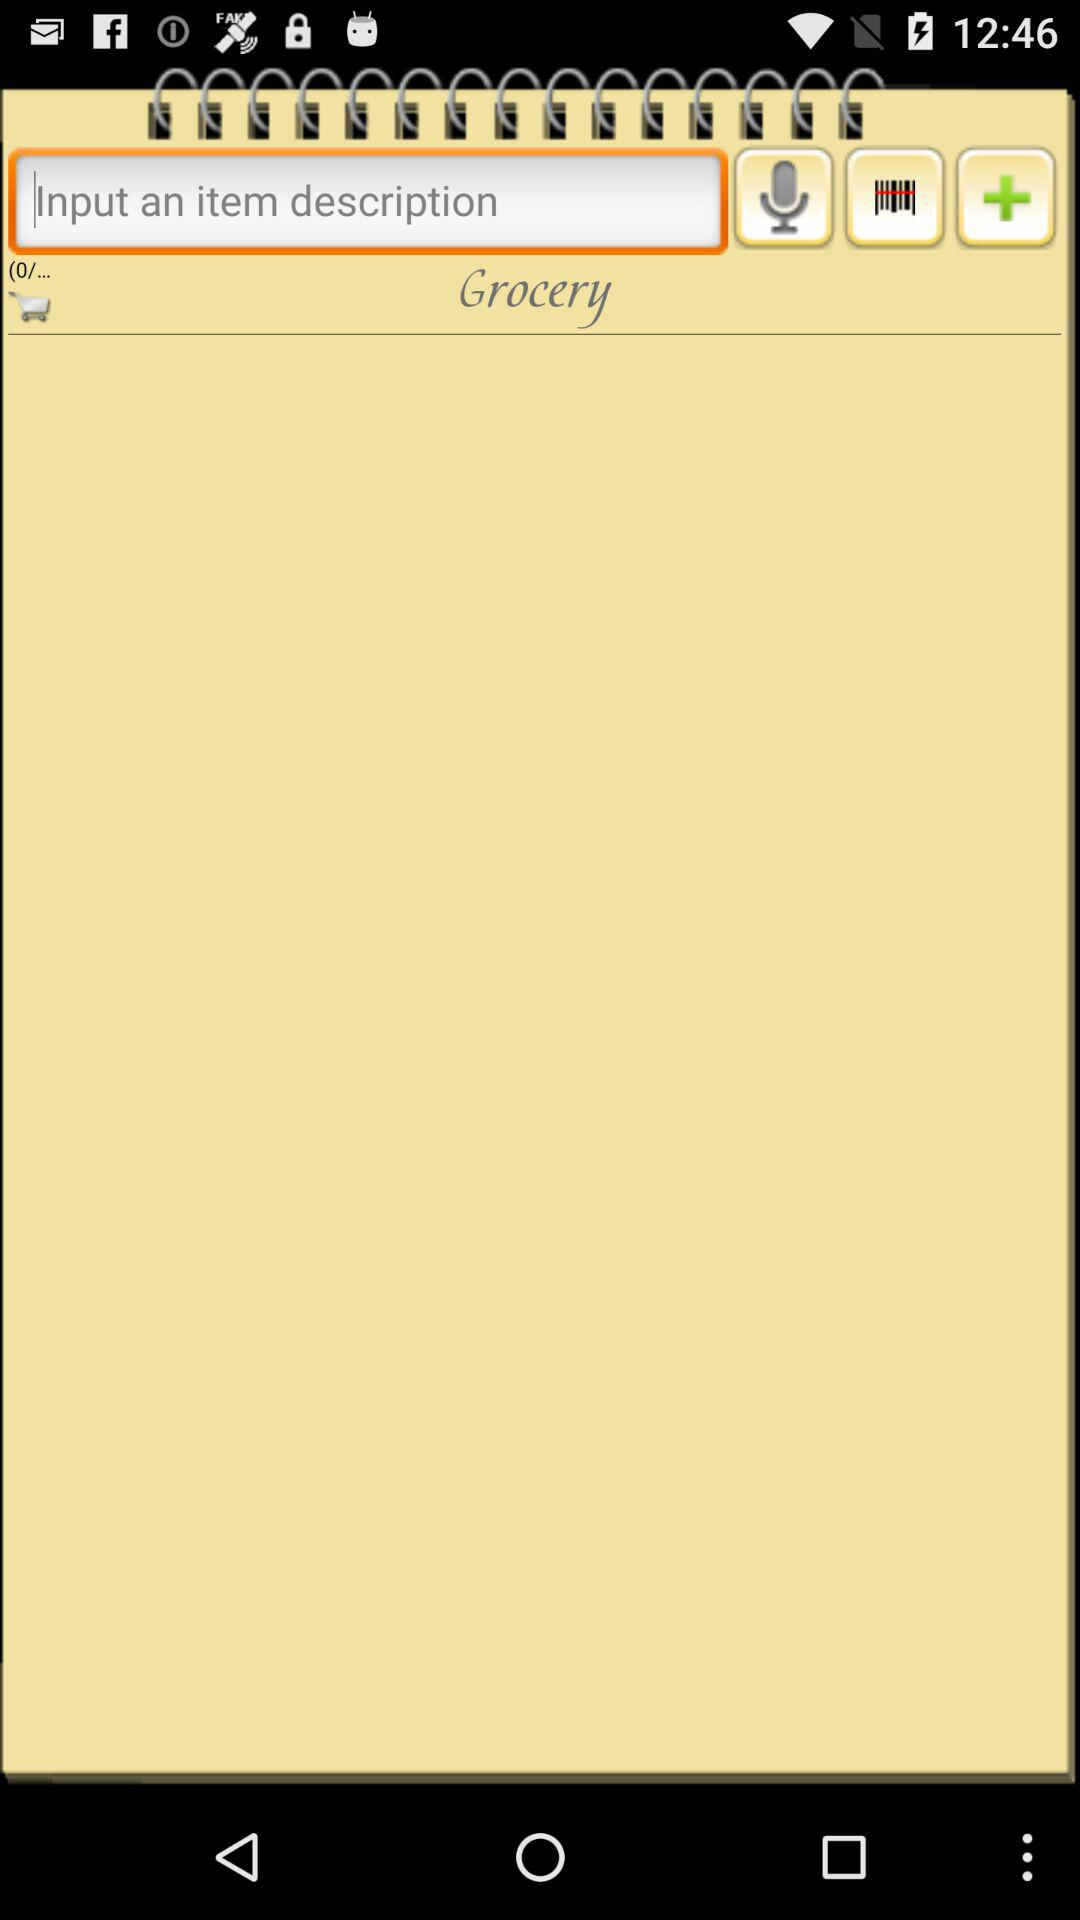How many orders are in the cart? There are 0 orders in the cart. 